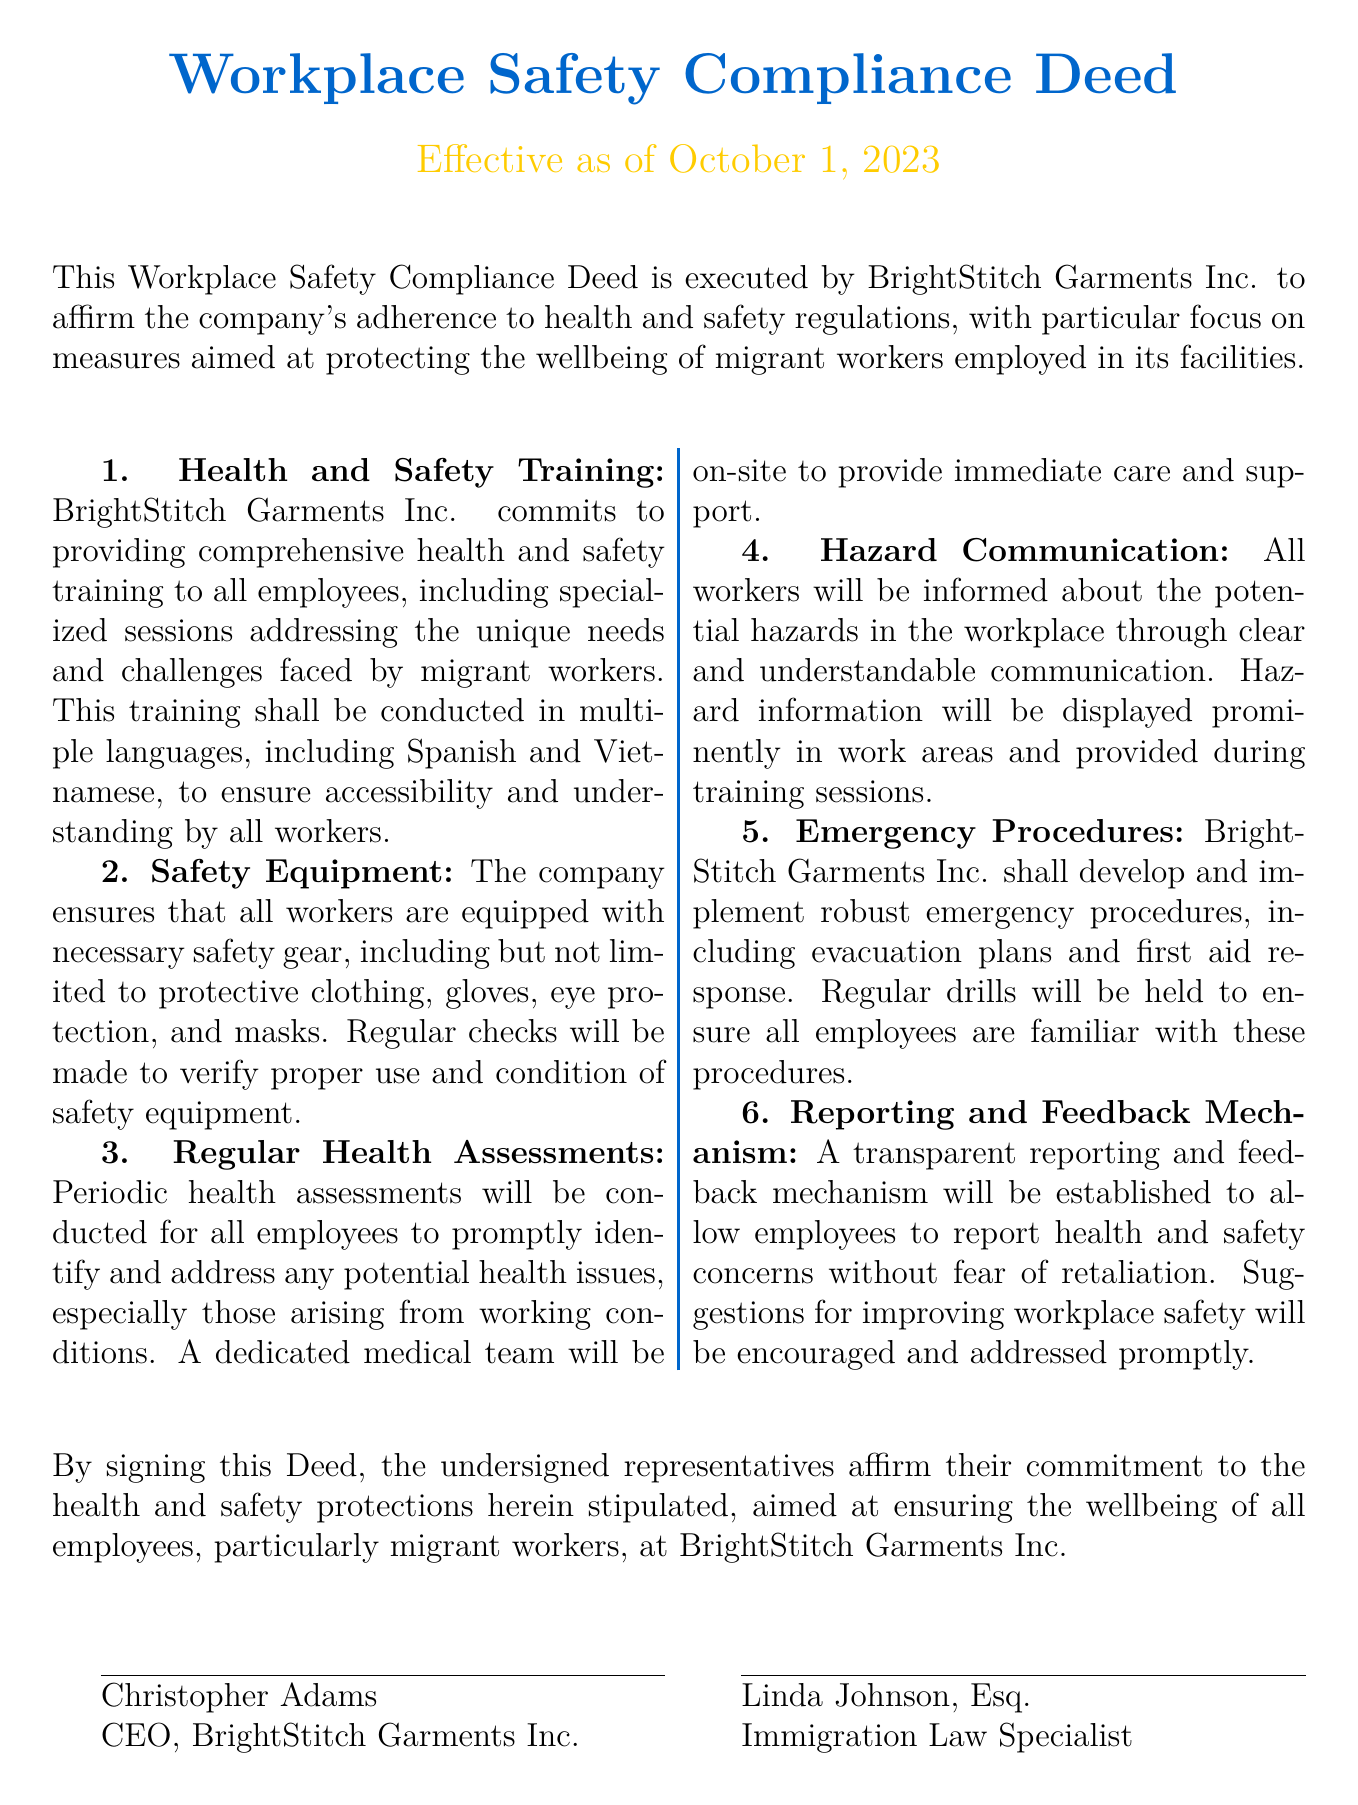What is the name of the company executing the Deed? The company executing the Deed is clearly stated at the beginning of the document.
Answer: BrightStitch Garments Inc What is the effective date of the Deed? The effective date is mentioned immediately after the title of the document.
Answer: October 1, 2023 Who is the CEO of BrightStitch Garments Inc.? The document lists the name of the individual representing the company as the CEO.
Answer: Christopher Adams What type of training will the company provide? The document specifies the type of training provided to employees, particularly for migrant workers.
Answer: Comprehensive health and safety training What equipment will be provided to workers? The Deed outlines specific safety gear that must be provided to all workers.
Answer: Necessary safety gear What will the company establish for reporting health and safety concerns? The document mentions the mechanism that will be put in place for employees to report concerns.
Answer: Transparent reporting and feedback mechanism How often will health assessments be conducted? The Deed indicates the frequency of health assessments for employees.
Answer: Periodic What languages will the training sessions be conducted in? The document specifies the languages used in training sessions for better communication.
Answer: Spanish and Vietnamese What emergency procedure will be implemented? The document details a specific plan related to emergencies that will be developed.
Answer: Robust emergency procedures 